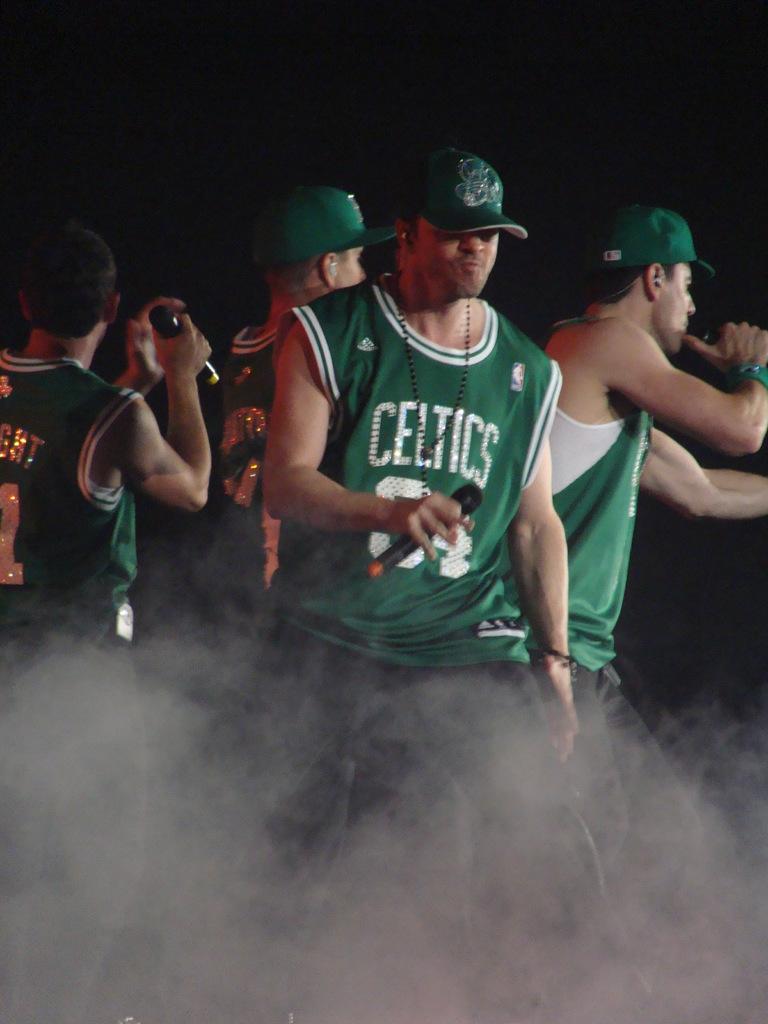What team jersey is that?
Offer a very short reply. Celtics. 